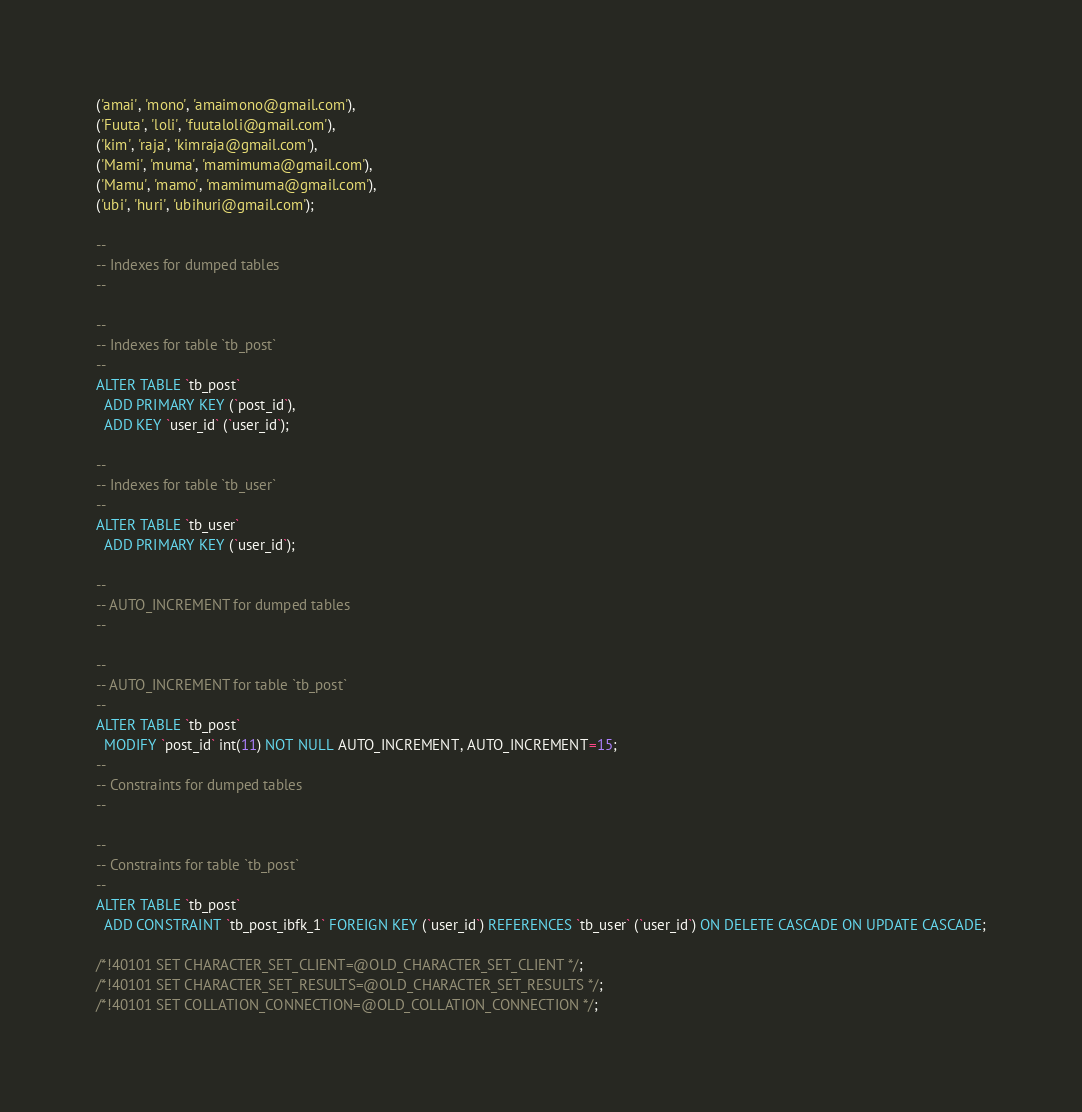<code> <loc_0><loc_0><loc_500><loc_500><_SQL_>('amai', 'mono', 'amaimono@gmail.com'),
('Fuuta', 'loli', 'fuutaloli@gmail.com'),
('kim', 'raja', 'kimraja@gmail.com'),
('Mami', 'muma', 'mamimuma@gmail.com'),
('Mamu', 'mamo', 'mamimuma@gmail.com'),
('ubi', 'huri', 'ubihuri@gmail.com');

--
-- Indexes for dumped tables
--

--
-- Indexes for table `tb_post`
--
ALTER TABLE `tb_post`
  ADD PRIMARY KEY (`post_id`),
  ADD KEY `user_id` (`user_id`);

--
-- Indexes for table `tb_user`
--
ALTER TABLE `tb_user`
  ADD PRIMARY KEY (`user_id`);

--
-- AUTO_INCREMENT for dumped tables
--

--
-- AUTO_INCREMENT for table `tb_post`
--
ALTER TABLE `tb_post`
  MODIFY `post_id` int(11) NOT NULL AUTO_INCREMENT, AUTO_INCREMENT=15;
--
-- Constraints for dumped tables
--

--
-- Constraints for table `tb_post`
--
ALTER TABLE `tb_post`
  ADD CONSTRAINT `tb_post_ibfk_1` FOREIGN KEY (`user_id`) REFERENCES `tb_user` (`user_id`) ON DELETE CASCADE ON UPDATE CASCADE;

/*!40101 SET CHARACTER_SET_CLIENT=@OLD_CHARACTER_SET_CLIENT */;
/*!40101 SET CHARACTER_SET_RESULTS=@OLD_CHARACTER_SET_RESULTS */;
/*!40101 SET COLLATION_CONNECTION=@OLD_COLLATION_CONNECTION */;
</code> 